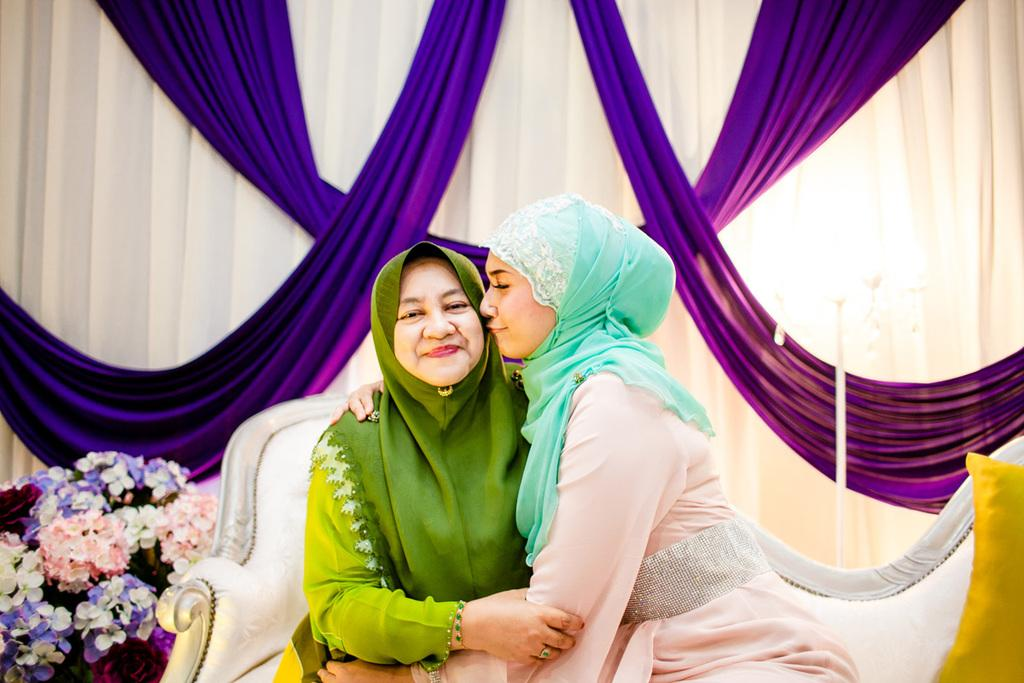How many people are in the image? There are two women in the image. What can be seen in the background or surrounding the women? Flowers, curtains, and lights are visible in the image. What type of soap is being used by the giants in the image? There are no giants present in the image, and therefore no soap usage can be observed. 